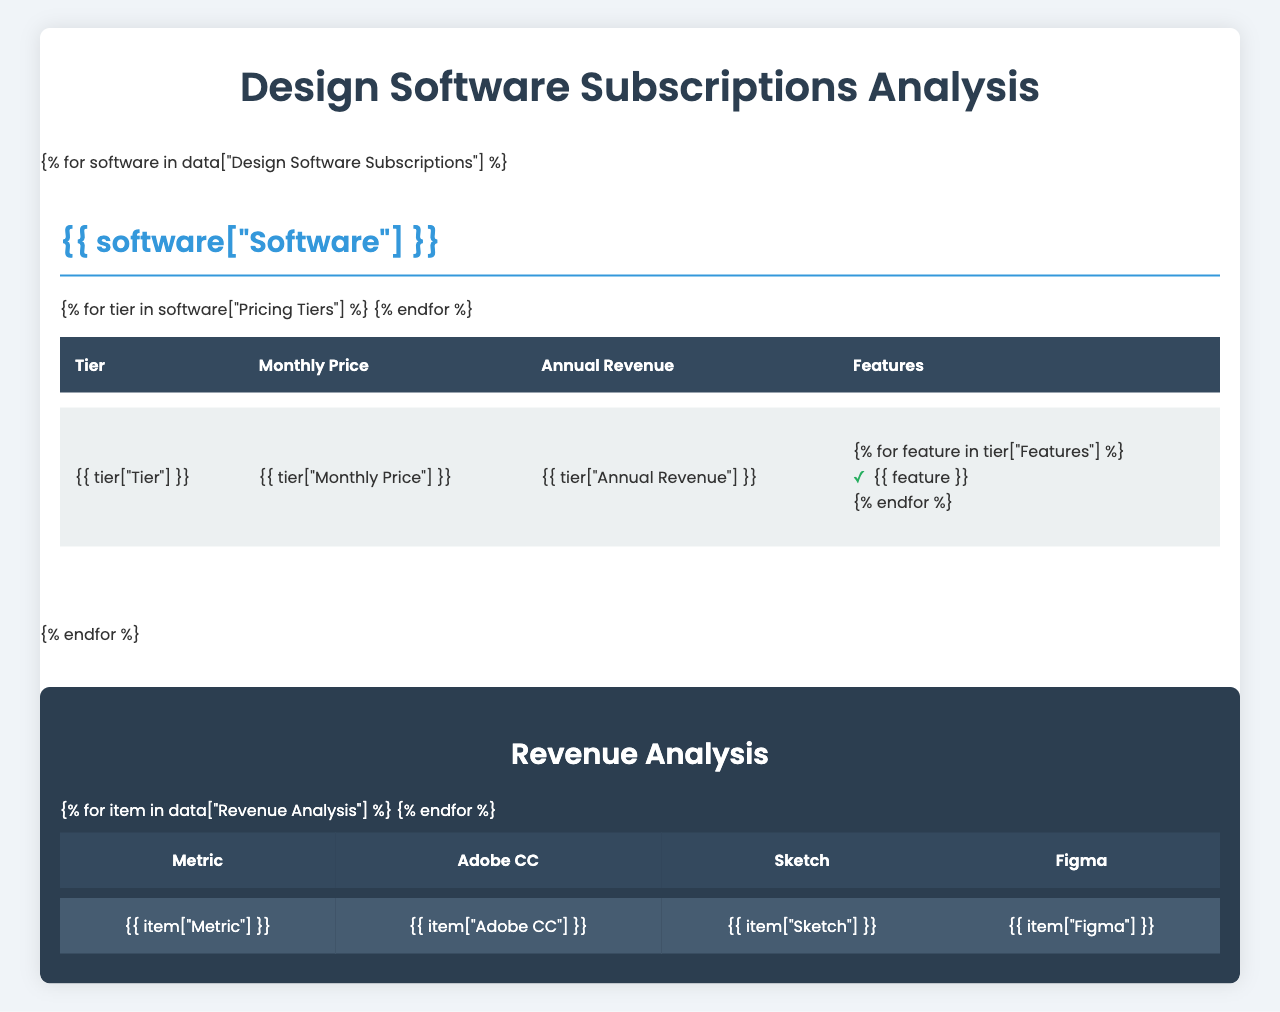What is the monthly price for the Business tier of Adobe Creative Cloud? The table lists the Adobe Creative Cloud pricing tiers, and under the Business tier, the Monthly Price is shown as $79.99.
Answer: $79.99 What features are included in the Student & Teacher tier of Adobe Creative Cloud? The features listed for the Student & Teacher tier in Adobe Creative Cloud are: All Creative Cloud apps, 100GB cloud storage, and Portfolio website.
Answer: All Creative Cloud apps, 100GB cloud storage, Portfolio website Which design software has the highest annual revenue for its Business tier? By checking the annual revenue values for each software's Business tier, Adobe Creative Cloud shows $959.88, while Sketch shows $240. Therefore, Adobe Creative Cloud has the highest annual revenue.
Answer: Adobe Creative Cloud What is the Average Revenue Per User for Figma? In the Revenue Analysis section, the ARPU for Figma is listed as $228.
Answer: $228 What is the total monthly price for all individual tiers across the three software options? The monthly prices for individual tiers are $52.99 (Adobe CC) + $9 (Sketch) + $0 (Figma), which sums up to $61.99.
Answer: $61.99 Does Figma offer a free tier? The Starter tier of Figma is listed with a monthly price of $0, which confirms that Figma does offer a free tier.
Answer: Yes What is the difference in Annual Revenue between the Individual and Business tiers of Adobe Creative Cloud? The Annual Revenue for the Individual tier is $635.88 while for the Business tier it is $959.88. The difference is $959.88 - $635.88 = $324.
Answer: $324 Which software has the highest Monthly Recurring Revenue (MRR)? The MRR for each software is given: Adobe CC is $15.2M, Sketch is $3.8M, and Figma is $9.5M. Adobe CC has the highest MRR at $15.2M.
Answer: Adobe Creative Cloud What is the churn rate for Sketch and Figma combined? The churn rates for each are 7.2% (Sketch) + 5.8% (Figma). To find the combined churn rate, we take the average: (7.2 + 5.8) / 2 = 6.5%.
Answer: 6.5% What features are unique to the Organization tier of Figma compared to its other tiers? Checking the features of the Organization tier, they include Advanced security, Centralized team management, and Design system analytics, which are not found in the Starter or Professional tiers.
Answer: Advanced security, Centralized team management, Design system analytics 